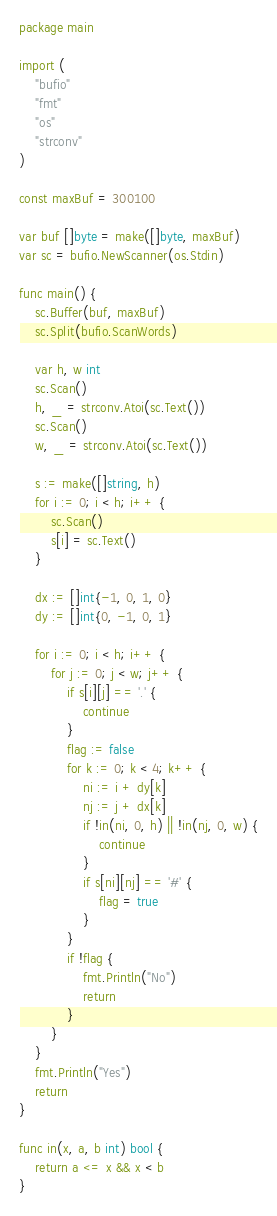<code> <loc_0><loc_0><loc_500><loc_500><_Go_>package main

import (
	"bufio"
	"fmt"
	"os"
	"strconv"
)

const maxBuf = 300100

var buf []byte = make([]byte, maxBuf)
var sc = bufio.NewScanner(os.Stdin)

func main() {
	sc.Buffer(buf, maxBuf)
	sc.Split(bufio.ScanWords)

	var h, w int
	sc.Scan()
	h, _ = strconv.Atoi(sc.Text())
	sc.Scan()
	w, _ = strconv.Atoi(sc.Text())

	s := make([]string, h)
	for i := 0; i < h; i++ {
		sc.Scan()
		s[i] = sc.Text()
	}

	dx := []int{-1, 0, 1, 0}
	dy := []int{0, -1, 0, 1}

	for i := 0; i < h; i++ {
		for j := 0; j < w; j++ {
			if s[i][j] == '.' {
				continue
			}
			flag := false
			for k := 0; k < 4; k++ {
				ni := i + dy[k]
				nj := j + dx[k]
				if !in(ni, 0, h) || !in(nj, 0, w) {
					continue
				}
				if s[ni][nj] == '#' {
					flag = true
				}
			}
			if !flag {
				fmt.Println("No")
				return
			}
		}
	}
	fmt.Println("Yes")
	return
}

func in(x, a, b int) bool {
	return a <= x && x < b
}
</code> 